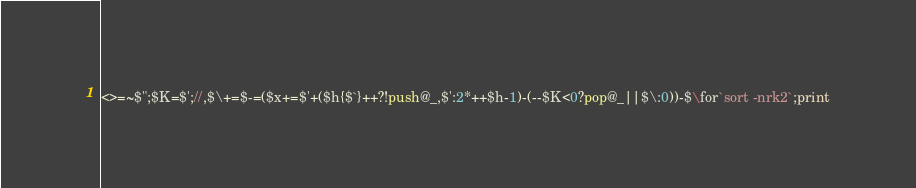<code> <loc_0><loc_0><loc_500><loc_500><_Perl_><>=~$";$K=$';//,$\+=$-=($x+=$'+($h{$`}++?!push@_,$':2*++$h-1)-(--$K<0?pop@_||$\:0))-$\for`sort -nrk2`;print</code> 